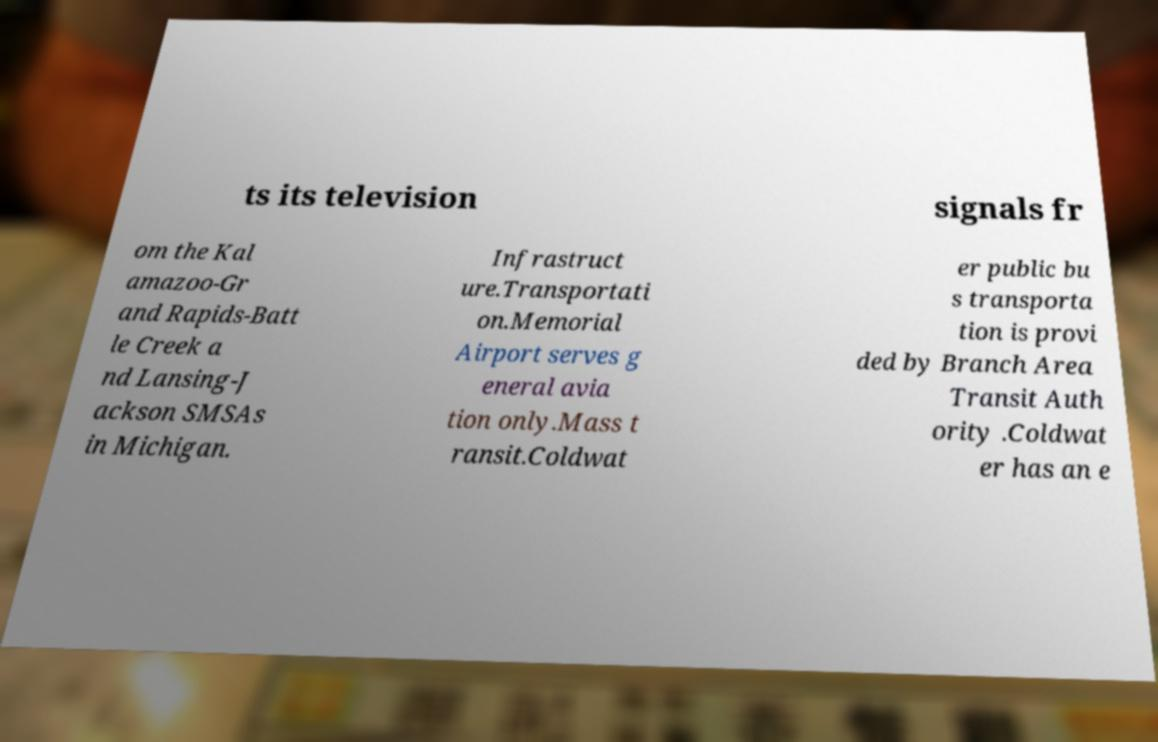There's text embedded in this image that I need extracted. Can you transcribe it verbatim? ts its television signals fr om the Kal amazoo-Gr and Rapids-Batt le Creek a nd Lansing-J ackson SMSAs in Michigan. Infrastruct ure.Transportati on.Memorial Airport serves g eneral avia tion only.Mass t ransit.Coldwat er public bu s transporta tion is provi ded by Branch Area Transit Auth ority .Coldwat er has an e 